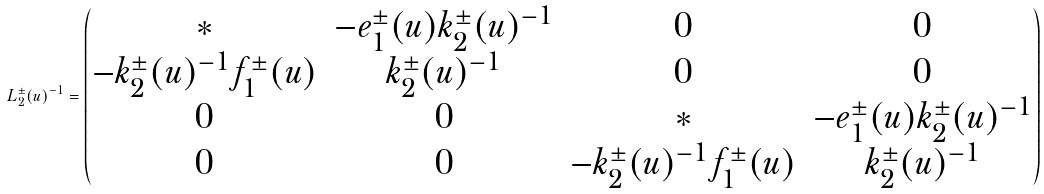Convert formula to latex. <formula><loc_0><loc_0><loc_500><loc_500>L _ { 2 } ^ { \pm } ( u ) ^ { - 1 } = \begin{pmatrix} * & - e _ { 1 } ^ { \pm } ( u ) k _ { 2 } ^ { \pm } ( u ) ^ { - 1 } & 0 & 0 \\ - k _ { 2 } ^ { \pm } ( u ) ^ { - 1 } f _ { 1 } ^ { \pm } ( u ) & k _ { 2 } ^ { \pm } ( u ) ^ { - 1 } & 0 & 0 \\ 0 & 0 & * & - e _ { 1 } ^ { \pm } ( u ) k _ { 2 } ^ { \pm } ( u ) ^ { - 1 } \\ 0 & 0 & - k _ { 2 } ^ { \pm } ( u ) ^ { - 1 } f _ { 1 } ^ { \pm } ( u ) & k _ { 2 } ^ { \pm } ( u ) ^ { - 1 } \end{pmatrix}</formula> 